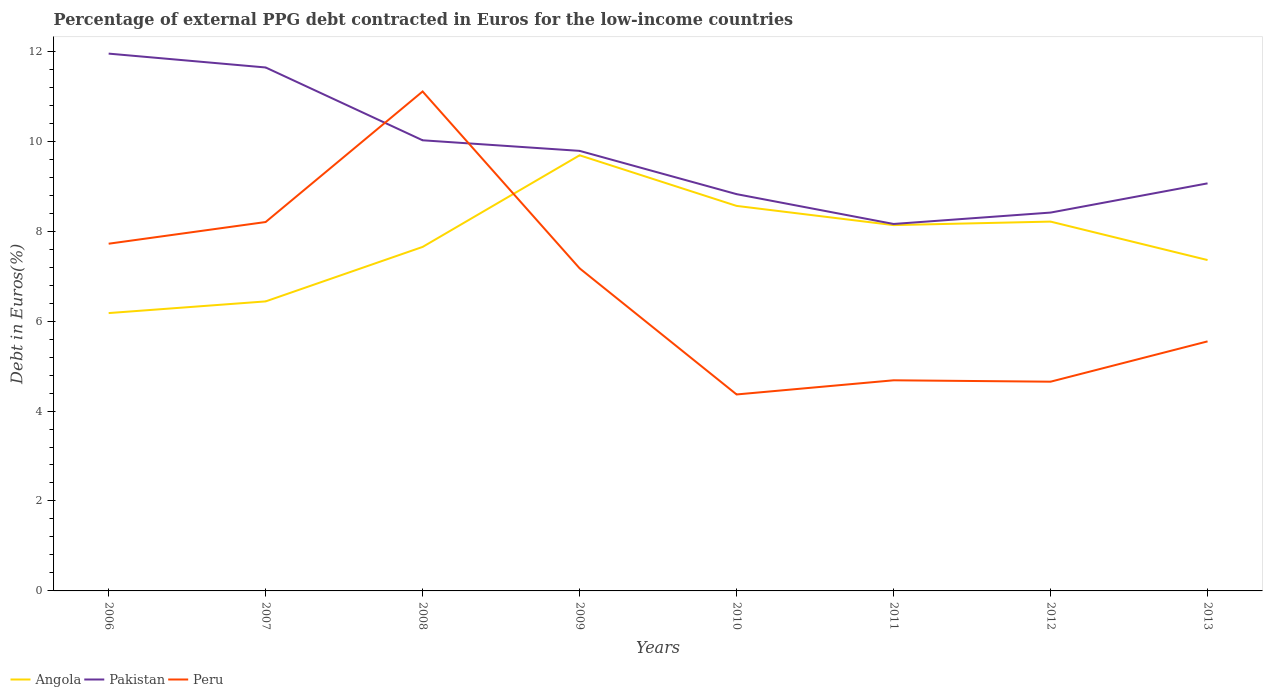How many different coloured lines are there?
Your response must be concise. 3. Does the line corresponding to Peru intersect with the line corresponding to Angola?
Offer a terse response. Yes. Is the number of lines equal to the number of legend labels?
Keep it short and to the point. Yes. Across all years, what is the maximum percentage of external PPG debt contracted in Euros in Angola?
Offer a terse response. 6.18. In which year was the percentage of external PPG debt contracted in Euros in Peru maximum?
Ensure brevity in your answer.  2010. What is the total percentage of external PPG debt contracted in Euros in Pakistan in the graph?
Make the answer very short. 2.88. What is the difference between the highest and the second highest percentage of external PPG debt contracted in Euros in Angola?
Give a very brief answer. 3.51. How many lines are there?
Your answer should be compact. 3. How many years are there in the graph?
Give a very brief answer. 8. Are the values on the major ticks of Y-axis written in scientific E-notation?
Keep it short and to the point. No. Does the graph contain any zero values?
Keep it short and to the point. No. Where does the legend appear in the graph?
Make the answer very short. Bottom left. What is the title of the graph?
Make the answer very short. Percentage of external PPG debt contracted in Euros for the low-income countries. What is the label or title of the X-axis?
Ensure brevity in your answer.  Years. What is the label or title of the Y-axis?
Ensure brevity in your answer.  Debt in Euros(%). What is the Debt in Euros(%) of Angola in 2006?
Offer a terse response. 6.18. What is the Debt in Euros(%) of Pakistan in 2006?
Ensure brevity in your answer.  11.95. What is the Debt in Euros(%) in Peru in 2006?
Keep it short and to the point. 7.72. What is the Debt in Euros(%) of Angola in 2007?
Ensure brevity in your answer.  6.44. What is the Debt in Euros(%) of Pakistan in 2007?
Offer a terse response. 11.64. What is the Debt in Euros(%) of Peru in 2007?
Offer a very short reply. 8.2. What is the Debt in Euros(%) in Angola in 2008?
Provide a short and direct response. 7.65. What is the Debt in Euros(%) of Pakistan in 2008?
Keep it short and to the point. 10.02. What is the Debt in Euros(%) in Peru in 2008?
Provide a short and direct response. 11.11. What is the Debt in Euros(%) of Angola in 2009?
Make the answer very short. 9.69. What is the Debt in Euros(%) of Pakistan in 2009?
Your answer should be compact. 9.78. What is the Debt in Euros(%) in Peru in 2009?
Make the answer very short. 7.17. What is the Debt in Euros(%) of Angola in 2010?
Your answer should be compact. 8.56. What is the Debt in Euros(%) of Pakistan in 2010?
Make the answer very short. 8.82. What is the Debt in Euros(%) in Peru in 2010?
Ensure brevity in your answer.  4.37. What is the Debt in Euros(%) of Angola in 2011?
Your answer should be compact. 8.13. What is the Debt in Euros(%) of Pakistan in 2011?
Give a very brief answer. 8.16. What is the Debt in Euros(%) in Peru in 2011?
Your response must be concise. 4.68. What is the Debt in Euros(%) of Angola in 2012?
Make the answer very short. 8.21. What is the Debt in Euros(%) of Pakistan in 2012?
Ensure brevity in your answer.  8.41. What is the Debt in Euros(%) in Peru in 2012?
Your answer should be compact. 4.65. What is the Debt in Euros(%) of Angola in 2013?
Your response must be concise. 7.36. What is the Debt in Euros(%) of Pakistan in 2013?
Ensure brevity in your answer.  9.06. What is the Debt in Euros(%) of Peru in 2013?
Provide a succinct answer. 5.55. Across all years, what is the maximum Debt in Euros(%) of Angola?
Your answer should be compact. 9.69. Across all years, what is the maximum Debt in Euros(%) of Pakistan?
Your answer should be very brief. 11.95. Across all years, what is the maximum Debt in Euros(%) of Peru?
Offer a very short reply. 11.11. Across all years, what is the minimum Debt in Euros(%) in Angola?
Offer a terse response. 6.18. Across all years, what is the minimum Debt in Euros(%) of Pakistan?
Make the answer very short. 8.16. Across all years, what is the minimum Debt in Euros(%) of Peru?
Offer a very short reply. 4.37. What is the total Debt in Euros(%) of Angola in the graph?
Ensure brevity in your answer.  62.21. What is the total Debt in Euros(%) of Pakistan in the graph?
Make the answer very short. 77.85. What is the total Debt in Euros(%) of Peru in the graph?
Keep it short and to the point. 53.45. What is the difference between the Debt in Euros(%) in Angola in 2006 and that in 2007?
Your answer should be very brief. -0.26. What is the difference between the Debt in Euros(%) of Pakistan in 2006 and that in 2007?
Offer a terse response. 0.31. What is the difference between the Debt in Euros(%) of Peru in 2006 and that in 2007?
Give a very brief answer. -0.48. What is the difference between the Debt in Euros(%) of Angola in 2006 and that in 2008?
Offer a terse response. -1.47. What is the difference between the Debt in Euros(%) of Pakistan in 2006 and that in 2008?
Provide a short and direct response. 1.93. What is the difference between the Debt in Euros(%) of Peru in 2006 and that in 2008?
Your response must be concise. -3.38. What is the difference between the Debt in Euros(%) of Angola in 2006 and that in 2009?
Give a very brief answer. -3.51. What is the difference between the Debt in Euros(%) in Pakistan in 2006 and that in 2009?
Make the answer very short. 2.16. What is the difference between the Debt in Euros(%) in Peru in 2006 and that in 2009?
Your answer should be compact. 0.55. What is the difference between the Debt in Euros(%) in Angola in 2006 and that in 2010?
Your response must be concise. -2.38. What is the difference between the Debt in Euros(%) of Pakistan in 2006 and that in 2010?
Provide a succinct answer. 3.12. What is the difference between the Debt in Euros(%) in Peru in 2006 and that in 2010?
Offer a very short reply. 3.35. What is the difference between the Debt in Euros(%) in Angola in 2006 and that in 2011?
Your response must be concise. -1.96. What is the difference between the Debt in Euros(%) of Pakistan in 2006 and that in 2011?
Your answer should be compact. 3.79. What is the difference between the Debt in Euros(%) of Peru in 2006 and that in 2011?
Ensure brevity in your answer.  3.04. What is the difference between the Debt in Euros(%) of Angola in 2006 and that in 2012?
Ensure brevity in your answer.  -2.03. What is the difference between the Debt in Euros(%) of Pakistan in 2006 and that in 2012?
Make the answer very short. 3.53. What is the difference between the Debt in Euros(%) of Peru in 2006 and that in 2012?
Your answer should be compact. 3.07. What is the difference between the Debt in Euros(%) of Angola in 2006 and that in 2013?
Provide a short and direct response. -1.18. What is the difference between the Debt in Euros(%) in Pakistan in 2006 and that in 2013?
Ensure brevity in your answer.  2.88. What is the difference between the Debt in Euros(%) of Peru in 2006 and that in 2013?
Provide a succinct answer. 2.17. What is the difference between the Debt in Euros(%) in Angola in 2007 and that in 2008?
Your response must be concise. -1.21. What is the difference between the Debt in Euros(%) of Pakistan in 2007 and that in 2008?
Your answer should be very brief. 1.62. What is the difference between the Debt in Euros(%) in Peru in 2007 and that in 2008?
Your response must be concise. -2.9. What is the difference between the Debt in Euros(%) in Angola in 2007 and that in 2009?
Your response must be concise. -3.25. What is the difference between the Debt in Euros(%) of Pakistan in 2007 and that in 2009?
Ensure brevity in your answer.  1.85. What is the difference between the Debt in Euros(%) in Peru in 2007 and that in 2009?
Keep it short and to the point. 1.03. What is the difference between the Debt in Euros(%) in Angola in 2007 and that in 2010?
Your answer should be very brief. -2.12. What is the difference between the Debt in Euros(%) in Pakistan in 2007 and that in 2010?
Your response must be concise. 2.82. What is the difference between the Debt in Euros(%) in Peru in 2007 and that in 2010?
Provide a succinct answer. 3.83. What is the difference between the Debt in Euros(%) in Angola in 2007 and that in 2011?
Provide a succinct answer. -1.7. What is the difference between the Debt in Euros(%) in Pakistan in 2007 and that in 2011?
Your answer should be compact. 3.48. What is the difference between the Debt in Euros(%) of Peru in 2007 and that in 2011?
Offer a terse response. 3.52. What is the difference between the Debt in Euros(%) in Angola in 2007 and that in 2012?
Offer a terse response. -1.77. What is the difference between the Debt in Euros(%) of Pakistan in 2007 and that in 2012?
Make the answer very short. 3.23. What is the difference between the Debt in Euros(%) in Peru in 2007 and that in 2012?
Offer a very short reply. 3.55. What is the difference between the Debt in Euros(%) of Angola in 2007 and that in 2013?
Ensure brevity in your answer.  -0.92. What is the difference between the Debt in Euros(%) in Pakistan in 2007 and that in 2013?
Your answer should be compact. 2.58. What is the difference between the Debt in Euros(%) in Peru in 2007 and that in 2013?
Provide a succinct answer. 2.65. What is the difference between the Debt in Euros(%) in Angola in 2008 and that in 2009?
Provide a short and direct response. -2.04. What is the difference between the Debt in Euros(%) in Pakistan in 2008 and that in 2009?
Provide a succinct answer. 0.24. What is the difference between the Debt in Euros(%) of Peru in 2008 and that in 2009?
Ensure brevity in your answer.  3.93. What is the difference between the Debt in Euros(%) in Angola in 2008 and that in 2010?
Give a very brief answer. -0.91. What is the difference between the Debt in Euros(%) of Pakistan in 2008 and that in 2010?
Give a very brief answer. 1.2. What is the difference between the Debt in Euros(%) of Peru in 2008 and that in 2010?
Make the answer very short. 6.74. What is the difference between the Debt in Euros(%) of Angola in 2008 and that in 2011?
Your answer should be compact. -0.48. What is the difference between the Debt in Euros(%) of Pakistan in 2008 and that in 2011?
Ensure brevity in your answer.  1.86. What is the difference between the Debt in Euros(%) in Peru in 2008 and that in 2011?
Keep it short and to the point. 6.42. What is the difference between the Debt in Euros(%) of Angola in 2008 and that in 2012?
Make the answer very short. -0.56. What is the difference between the Debt in Euros(%) in Pakistan in 2008 and that in 2012?
Your answer should be very brief. 1.61. What is the difference between the Debt in Euros(%) of Peru in 2008 and that in 2012?
Provide a succinct answer. 6.45. What is the difference between the Debt in Euros(%) of Angola in 2008 and that in 2013?
Keep it short and to the point. 0.29. What is the difference between the Debt in Euros(%) of Pakistan in 2008 and that in 2013?
Ensure brevity in your answer.  0.96. What is the difference between the Debt in Euros(%) in Peru in 2008 and that in 2013?
Make the answer very short. 5.56. What is the difference between the Debt in Euros(%) in Angola in 2009 and that in 2010?
Offer a terse response. 1.13. What is the difference between the Debt in Euros(%) of Pakistan in 2009 and that in 2010?
Give a very brief answer. 0.96. What is the difference between the Debt in Euros(%) in Peru in 2009 and that in 2010?
Your answer should be very brief. 2.8. What is the difference between the Debt in Euros(%) in Angola in 2009 and that in 2011?
Keep it short and to the point. 1.55. What is the difference between the Debt in Euros(%) in Pakistan in 2009 and that in 2011?
Your answer should be very brief. 1.63. What is the difference between the Debt in Euros(%) in Peru in 2009 and that in 2011?
Make the answer very short. 2.49. What is the difference between the Debt in Euros(%) in Angola in 2009 and that in 2012?
Provide a short and direct response. 1.47. What is the difference between the Debt in Euros(%) in Pakistan in 2009 and that in 2012?
Make the answer very short. 1.37. What is the difference between the Debt in Euros(%) of Peru in 2009 and that in 2012?
Make the answer very short. 2.52. What is the difference between the Debt in Euros(%) of Angola in 2009 and that in 2013?
Your response must be concise. 2.33. What is the difference between the Debt in Euros(%) in Pakistan in 2009 and that in 2013?
Your answer should be compact. 0.72. What is the difference between the Debt in Euros(%) in Peru in 2009 and that in 2013?
Your answer should be very brief. 1.62. What is the difference between the Debt in Euros(%) in Angola in 2010 and that in 2011?
Ensure brevity in your answer.  0.43. What is the difference between the Debt in Euros(%) of Pakistan in 2010 and that in 2011?
Provide a succinct answer. 0.66. What is the difference between the Debt in Euros(%) of Peru in 2010 and that in 2011?
Provide a succinct answer. -0.31. What is the difference between the Debt in Euros(%) of Angola in 2010 and that in 2012?
Provide a succinct answer. 0.35. What is the difference between the Debt in Euros(%) of Pakistan in 2010 and that in 2012?
Provide a succinct answer. 0.41. What is the difference between the Debt in Euros(%) of Peru in 2010 and that in 2012?
Keep it short and to the point. -0.28. What is the difference between the Debt in Euros(%) in Angola in 2010 and that in 2013?
Make the answer very short. 1.2. What is the difference between the Debt in Euros(%) in Pakistan in 2010 and that in 2013?
Your answer should be compact. -0.24. What is the difference between the Debt in Euros(%) in Peru in 2010 and that in 2013?
Offer a terse response. -1.18. What is the difference between the Debt in Euros(%) in Angola in 2011 and that in 2012?
Your answer should be compact. -0.08. What is the difference between the Debt in Euros(%) of Pakistan in 2011 and that in 2012?
Ensure brevity in your answer.  -0.25. What is the difference between the Debt in Euros(%) of Peru in 2011 and that in 2012?
Provide a short and direct response. 0.03. What is the difference between the Debt in Euros(%) in Angola in 2011 and that in 2013?
Your answer should be very brief. 0.78. What is the difference between the Debt in Euros(%) in Pakistan in 2011 and that in 2013?
Provide a succinct answer. -0.9. What is the difference between the Debt in Euros(%) of Peru in 2011 and that in 2013?
Ensure brevity in your answer.  -0.87. What is the difference between the Debt in Euros(%) in Angola in 2012 and that in 2013?
Your answer should be compact. 0.86. What is the difference between the Debt in Euros(%) in Pakistan in 2012 and that in 2013?
Ensure brevity in your answer.  -0.65. What is the difference between the Debt in Euros(%) in Peru in 2012 and that in 2013?
Ensure brevity in your answer.  -0.9. What is the difference between the Debt in Euros(%) of Angola in 2006 and the Debt in Euros(%) of Pakistan in 2007?
Offer a terse response. -5.46. What is the difference between the Debt in Euros(%) in Angola in 2006 and the Debt in Euros(%) in Peru in 2007?
Ensure brevity in your answer.  -2.02. What is the difference between the Debt in Euros(%) of Pakistan in 2006 and the Debt in Euros(%) of Peru in 2007?
Provide a short and direct response. 3.74. What is the difference between the Debt in Euros(%) in Angola in 2006 and the Debt in Euros(%) in Pakistan in 2008?
Give a very brief answer. -3.84. What is the difference between the Debt in Euros(%) in Angola in 2006 and the Debt in Euros(%) in Peru in 2008?
Keep it short and to the point. -4.93. What is the difference between the Debt in Euros(%) of Pakistan in 2006 and the Debt in Euros(%) of Peru in 2008?
Give a very brief answer. 0.84. What is the difference between the Debt in Euros(%) of Angola in 2006 and the Debt in Euros(%) of Pakistan in 2009?
Your answer should be very brief. -3.61. What is the difference between the Debt in Euros(%) of Angola in 2006 and the Debt in Euros(%) of Peru in 2009?
Ensure brevity in your answer.  -1. What is the difference between the Debt in Euros(%) of Pakistan in 2006 and the Debt in Euros(%) of Peru in 2009?
Keep it short and to the point. 4.77. What is the difference between the Debt in Euros(%) in Angola in 2006 and the Debt in Euros(%) in Pakistan in 2010?
Give a very brief answer. -2.64. What is the difference between the Debt in Euros(%) of Angola in 2006 and the Debt in Euros(%) of Peru in 2010?
Give a very brief answer. 1.81. What is the difference between the Debt in Euros(%) of Pakistan in 2006 and the Debt in Euros(%) of Peru in 2010?
Offer a terse response. 7.58. What is the difference between the Debt in Euros(%) in Angola in 2006 and the Debt in Euros(%) in Pakistan in 2011?
Your response must be concise. -1.98. What is the difference between the Debt in Euros(%) of Angola in 2006 and the Debt in Euros(%) of Peru in 2011?
Keep it short and to the point. 1.49. What is the difference between the Debt in Euros(%) in Pakistan in 2006 and the Debt in Euros(%) in Peru in 2011?
Give a very brief answer. 7.26. What is the difference between the Debt in Euros(%) in Angola in 2006 and the Debt in Euros(%) in Pakistan in 2012?
Ensure brevity in your answer.  -2.23. What is the difference between the Debt in Euros(%) of Angola in 2006 and the Debt in Euros(%) of Peru in 2012?
Your response must be concise. 1.53. What is the difference between the Debt in Euros(%) of Pakistan in 2006 and the Debt in Euros(%) of Peru in 2012?
Give a very brief answer. 7.29. What is the difference between the Debt in Euros(%) of Angola in 2006 and the Debt in Euros(%) of Pakistan in 2013?
Your answer should be very brief. -2.88. What is the difference between the Debt in Euros(%) of Angola in 2006 and the Debt in Euros(%) of Peru in 2013?
Offer a terse response. 0.63. What is the difference between the Debt in Euros(%) in Pakistan in 2006 and the Debt in Euros(%) in Peru in 2013?
Offer a very short reply. 6.4. What is the difference between the Debt in Euros(%) in Angola in 2007 and the Debt in Euros(%) in Pakistan in 2008?
Provide a short and direct response. -3.58. What is the difference between the Debt in Euros(%) in Angola in 2007 and the Debt in Euros(%) in Peru in 2008?
Offer a terse response. -4.67. What is the difference between the Debt in Euros(%) in Pakistan in 2007 and the Debt in Euros(%) in Peru in 2008?
Offer a very short reply. 0.53. What is the difference between the Debt in Euros(%) in Angola in 2007 and the Debt in Euros(%) in Pakistan in 2009?
Give a very brief answer. -3.35. What is the difference between the Debt in Euros(%) in Angola in 2007 and the Debt in Euros(%) in Peru in 2009?
Provide a short and direct response. -0.74. What is the difference between the Debt in Euros(%) of Pakistan in 2007 and the Debt in Euros(%) of Peru in 2009?
Give a very brief answer. 4.47. What is the difference between the Debt in Euros(%) in Angola in 2007 and the Debt in Euros(%) in Pakistan in 2010?
Ensure brevity in your answer.  -2.38. What is the difference between the Debt in Euros(%) of Angola in 2007 and the Debt in Euros(%) of Peru in 2010?
Provide a short and direct response. 2.07. What is the difference between the Debt in Euros(%) in Pakistan in 2007 and the Debt in Euros(%) in Peru in 2010?
Provide a succinct answer. 7.27. What is the difference between the Debt in Euros(%) of Angola in 2007 and the Debt in Euros(%) of Pakistan in 2011?
Keep it short and to the point. -1.72. What is the difference between the Debt in Euros(%) of Angola in 2007 and the Debt in Euros(%) of Peru in 2011?
Keep it short and to the point. 1.75. What is the difference between the Debt in Euros(%) of Pakistan in 2007 and the Debt in Euros(%) of Peru in 2011?
Provide a succinct answer. 6.96. What is the difference between the Debt in Euros(%) of Angola in 2007 and the Debt in Euros(%) of Pakistan in 2012?
Keep it short and to the point. -1.98. What is the difference between the Debt in Euros(%) of Angola in 2007 and the Debt in Euros(%) of Peru in 2012?
Your response must be concise. 1.79. What is the difference between the Debt in Euros(%) of Pakistan in 2007 and the Debt in Euros(%) of Peru in 2012?
Make the answer very short. 6.99. What is the difference between the Debt in Euros(%) in Angola in 2007 and the Debt in Euros(%) in Pakistan in 2013?
Your answer should be very brief. -2.62. What is the difference between the Debt in Euros(%) of Angola in 2007 and the Debt in Euros(%) of Peru in 2013?
Keep it short and to the point. 0.89. What is the difference between the Debt in Euros(%) of Pakistan in 2007 and the Debt in Euros(%) of Peru in 2013?
Your response must be concise. 6.09. What is the difference between the Debt in Euros(%) in Angola in 2008 and the Debt in Euros(%) in Pakistan in 2009?
Offer a very short reply. -2.14. What is the difference between the Debt in Euros(%) in Angola in 2008 and the Debt in Euros(%) in Peru in 2009?
Make the answer very short. 0.48. What is the difference between the Debt in Euros(%) of Pakistan in 2008 and the Debt in Euros(%) of Peru in 2009?
Provide a succinct answer. 2.85. What is the difference between the Debt in Euros(%) in Angola in 2008 and the Debt in Euros(%) in Pakistan in 2010?
Your answer should be compact. -1.17. What is the difference between the Debt in Euros(%) in Angola in 2008 and the Debt in Euros(%) in Peru in 2010?
Ensure brevity in your answer.  3.28. What is the difference between the Debt in Euros(%) in Pakistan in 2008 and the Debt in Euros(%) in Peru in 2010?
Provide a succinct answer. 5.65. What is the difference between the Debt in Euros(%) in Angola in 2008 and the Debt in Euros(%) in Pakistan in 2011?
Your response must be concise. -0.51. What is the difference between the Debt in Euros(%) of Angola in 2008 and the Debt in Euros(%) of Peru in 2011?
Keep it short and to the point. 2.97. What is the difference between the Debt in Euros(%) of Pakistan in 2008 and the Debt in Euros(%) of Peru in 2011?
Give a very brief answer. 5.34. What is the difference between the Debt in Euros(%) in Angola in 2008 and the Debt in Euros(%) in Pakistan in 2012?
Your response must be concise. -0.76. What is the difference between the Debt in Euros(%) of Angola in 2008 and the Debt in Euros(%) of Peru in 2012?
Provide a succinct answer. 3. What is the difference between the Debt in Euros(%) in Pakistan in 2008 and the Debt in Euros(%) in Peru in 2012?
Provide a succinct answer. 5.37. What is the difference between the Debt in Euros(%) of Angola in 2008 and the Debt in Euros(%) of Pakistan in 2013?
Make the answer very short. -1.41. What is the difference between the Debt in Euros(%) of Angola in 2008 and the Debt in Euros(%) of Peru in 2013?
Ensure brevity in your answer.  2.1. What is the difference between the Debt in Euros(%) in Pakistan in 2008 and the Debt in Euros(%) in Peru in 2013?
Provide a short and direct response. 4.47. What is the difference between the Debt in Euros(%) of Angola in 2009 and the Debt in Euros(%) of Pakistan in 2010?
Keep it short and to the point. 0.86. What is the difference between the Debt in Euros(%) of Angola in 2009 and the Debt in Euros(%) of Peru in 2010?
Offer a terse response. 5.32. What is the difference between the Debt in Euros(%) of Pakistan in 2009 and the Debt in Euros(%) of Peru in 2010?
Your response must be concise. 5.42. What is the difference between the Debt in Euros(%) of Angola in 2009 and the Debt in Euros(%) of Pakistan in 2011?
Give a very brief answer. 1.53. What is the difference between the Debt in Euros(%) in Angola in 2009 and the Debt in Euros(%) in Peru in 2011?
Make the answer very short. 5. What is the difference between the Debt in Euros(%) in Pakistan in 2009 and the Debt in Euros(%) in Peru in 2011?
Ensure brevity in your answer.  5.1. What is the difference between the Debt in Euros(%) of Angola in 2009 and the Debt in Euros(%) of Pakistan in 2012?
Make the answer very short. 1.27. What is the difference between the Debt in Euros(%) in Angola in 2009 and the Debt in Euros(%) in Peru in 2012?
Offer a very short reply. 5.03. What is the difference between the Debt in Euros(%) of Pakistan in 2009 and the Debt in Euros(%) of Peru in 2012?
Provide a succinct answer. 5.13. What is the difference between the Debt in Euros(%) of Angola in 2009 and the Debt in Euros(%) of Pakistan in 2013?
Keep it short and to the point. 0.62. What is the difference between the Debt in Euros(%) of Angola in 2009 and the Debt in Euros(%) of Peru in 2013?
Make the answer very short. 4.14. What is the difference between the Debt in Euros(%) of Pakistan in 2009 and the Debt in Euros(%) of Peru in 2013?
Keep it short and to the point. 4.24. What is the difference between the Debt in Euros(%) in Angola in 2010 and the Debt in Euros(%) in Pakistan in 2011?
Give a very brief answer. 0.4. What is the difference between the Debt in Euros(%) of Angola in 2010 and the Debt in Euros(%) of Peru in 2011?
Keep it short and to the point. 3.88. What is the difference between the Debt in Euros(%) of Pakistan in 2010 and the Debt in Euros(%) of Peru in 2011?
Your answer should be compact. 4.14. What is the difference between the Debt in Euros(%) of Angola in 2010 and the Debt in Euros(%) of Pakistan in 2012?
Offer a very short reply. 0.15. What is the difference between the Debt in Euros(%) in Angola in 2010 and the Debt in Euros(%) in Peru in 2012?
Give a very brief answer. 3.91. What is the difference between the Debt in Euros(%) of Pakistan in 2010 and the Debt in Euros(%) of Peru in 2012?
Your answer should be very brief. 4.17. What is the difference between the Debt in Euros(%) in Angola in 2010 and the Debt in Euros(%) in Pakistan in 2013?
Give a very brief answer. -0.5. What is the difference between the Debt in Euros(%) in Angola in 2010 and the Debt in Euros(%) in Peru in 2013?
Provide a short and direct response. 3.01. What is the difference between the Debt in Euros(%) of Pakistan in 2010 and the Debt in Euros(%) of Peru in 2013?
Offer a terse response. 3.27. What is the difference between the Debt in Euros(%) in Angola in 2011 and the Debt in Euros(%) in Pakistan in 2012?
Give a very brief answer. -0.28. What is the difference between the Debt in Euros(%) in Angola in 2011 and the Debt in Euros(%) in Peru in 2012?
Keep it short and to the point. 3.48. What is the difference between the Debt in Euros(%) of Pakistan in 2011 and the Debt in Euros(%) of Peru in 2012?
Offer a terse response. 3.51. What is the difference between the Debt in Euros(%) of Angola in 2011 and the Debt in Euros(%) of Pakistan in 2013?
Your response must be concise. -0.93. What is the difference between the Debt in Euros(%) in Angola in 2011 and the Debt in Euros(%) in Peru in 2013?
Provide a succinct answer. 2.58. What is the difference between the Debt in Euros(%) in Pakistan in 2011 and the Debt in Euros(%) in Peru in 2013?
Provide a succinct answer. 2.61. What is the difference between the Debt in Euros(%) in Angola in 2012 and the Debt in Euros(%) in Pakistan in 2013?
Your answer should be compact. -0.85. What is the difference between the Debt in Euros(%) in Angola in 2012 and the Debt in Euros(%) in Peru in 2013?
Give a very brief answer. 2.66. What is the difference between the Debt in Euros(%) of Pakistan in 2012 and the Debt in Euros(%) of Peru in 2013?
Ensure brevity in your answer.  2.86. What is the average Debt in Euros(%) of Angola per year?
Provide a succinct answer. 7.78. What is the average Debt in Euros(%) in Pakistan per year?
Provide a succinct answer. 9.73. What is the average Debt in Euros(%) of Peru per year?
Provide a succinct answer. 6.68. In the year 2006, what is the difference between the Debt in Euros(%) of Angola and Debt in Euros(%) of Pakistan?
Offer a very short reply. -5.77. In the year 2006, what is the difference between the Debt in Euros(%) in Angola and Debt in Euros(%) in Peru?
Offer a terse response. -1.54. In the year 2006, what is the difference between the Debt in Euros(%) in Pakistan and Debt in Euros(%) in Peru?
Give a very brief answer. 4.23. In the year 2007, what is the difference between the Debt in Euros(%) in Angola and Debt in Euros(%) in Pakistan?
Your response must be concise. -5.2. In the year 2007, what is the difference between the Debt in Euros(%) in Angola and Debt in Euros(%) in Peru?
Keep it short and to the point. -1.77. In the year 2007, what is the difference between the Debt in Euros(%) in Pakistan and Debt in Euros(%) in Peru?
Ensure brevity in your answer.  3.44. In the year 2008, what is the difference between the Debt in Euros(%) of Angola and Debt in Euros(%) of Pakistan?
Your answer should be very brief. -2.37. In the year 2008, what is the difference between the Debt in Euros(%) of Angola and Debt in Euros(%) of Peru?
Keep it short and to the point. -3.46. In the year 2008, what is the difference between the Debt in Euros(%) in Pakistan and Debt in Euros(%) in Peru?
Your answer should be compact. -1.09. In the year 2009, what is the difference between the Debt in Euros(%) in Angola and Debt in Euros(%) in Pakistan?
Ensure brevity in your answer.  -0.1. In the year 2009, what is the difference between the Debt in Euros(%) in Angola and Debt in Euros(%) in Peru?
Ensure brevity in your answer.  2.51. In the year 2009, what is the difference between the Debt in Euros(%) in Pakistan and Debt in Euros(%) in Peru?
Offer a terse response. 2.61. In the year 2010, what is the difference between the Debt in Euros(%) in Angola and Debt in Euros(%) in Pakistan?
Your response must be concise. -0.26. In the year 2010, what is the difference between the Debt in Euros(%) in Angola and Debt in Euros(%) in Peru?
Offer a terse response. 4.19. In the year 2010, what is the difference between the Debt in Euros(%) in Pakistan and Debt in Euros(%) in Peru?
Make the answer very short. 4.45. In the year 2011, what is the difference between the Debt in Euros(%) in Angola and Debt in Euros(%) in Pakistan?
Offer a very short reply. -0.03. In the year 2011, what is the difference between the Debt in Euros(%) of Angola and Debt in Euros(%) of Peru?
Offer a terse response. 3.45. In the year 2011, what is the difference between the Debt in Euros(%) of Pakistan and Debt in Euros(%) of Peru?
Provide a short and direct response. 3.48. In the year 2012, what is the difference between the Debt in Euros(%) in Angola and Debt in Euros(%) in Pakistan?
Make the answer very short. -0.2. In the year 2012, what is the difference between the Debt in Euros(%) of Angola and Debt in Euros(%) of Peru?
Your answer should be very brief. 3.56. In the year 2012, what is the difference between the Debt in Euros(%) of Pakistan and Debt in Euros(%) of Peru?
Your answer should be compact. 3.76. In the year 2013, what is the difference between the Debt in Euros(%) in Angola and Debt in Euros(%) in Pakistan?
Provide a succinct answer. -1.71. In the year 2013, what is the difference between the Debt in Euros(%) in Angola and Debt in Euros(%) in Peru?
Keep it short and to the point. 1.81. In the year 2013, what is the difference between the Debt in Euros(%) of Pakistan and Debt in Euros(%) of Peru?
Offer a terse response. 3.51. What is the ratio of the Debt in Euros(%) of Angola in 2006 to that in 2007?
Provide a short and direct response. 0.96. What is the ratio of the Debt in Euros(%) of Pakistan in 2006 to that in 2007?
Offer a terse response. 1.03. What is the ratio of the Debt in Euros(%) of Peru in 2006 to that in 2007?
Give a very brief answer. 0.94. What is the ratio of the Debt in Euros(%) in Angola in 2006 to that in 2008?
Provide a short and direct response. 0.81. What is the ratio of the Debt in Euros(%) in Pakistan in 2006 to that in 2008?
Provide a short and direct response. 1.19. What is the ratio of the Debt in Euros(%) in Peru in 2006 to that in 2008?
Provide a short and direct response. 0.7. What is the ratio of the Debt in Euros(%) in Angola in 2006 to that in 2009?
Offer a very short reply. 0.64. What is the ratio of the Debt in Euros(%) in Pakistan in 2006 to that in 2009?
Give a very brief answer. 1.22. What is the ratio of the Debt in Euros(%) of Peru in 2006 to that in 2009?
Provide a short and direct response. 1.08. What is the ratio of the Debt in Euros(%) in Angola in 2006 to that in 2010?
Give a very brief answer. 0.72. What is the ratio of the Debt in Euros(%) in Pakistan in 2006 to that in 2010?
Give a very brief answer. 1.35. What is the ratio of the Debt in Euros(%) in Peru in 2006 to that in 2010?
Ensure brevity in your answer.  1.77. What is the ratio of the Debt in Euros(%) of Angola in 2006 to that in 2011?
Make the answer very short. 0.76. What is the ratio of the Debt in Euros(%) of Pakistan in 2006 to that in 2011?
Offer a terse response. 1.46. What is the ratio of the Debt in Euros(%) in Peru in 2006 to that in 2011?
Ensure brevity in your answer.  1.65. What is the ratio of the Debt in Euros(%) of Angola in 2006 to that in 2012?
Your answer should be very brief. 0.75. What is the ratio of the Debt in Euros(%) in Pakistan in 2006 to that in 2012?
Keep it short and to the point. 1.42. What is the ratio of the Debt in Euros(%) of Peru in 2006 to that in 2012?
Make the answer very short. 1.66. What is the ratio of the Debt in Euros(%) of Angola in 2006 to that in 2013?
Your response must be concise. 0.84. What is the ratio of the Debt in Euros(%) in Pakistan in 2006 to that in 2013?
Make the answer very short. 1.32. What is the ratio of the Debt in Euros(%) in Peru in 2006 to that in 2013?
Make the answer very short. 1.39. What is the ratio of the Debt in Euros(%) of Angola in 2007 to that in 2008?
Make the answer very short. 0.84. What is the ratio of the Debt in Euros(%) of Pakistan in 2007 to that in 2008?
Ensure brevity in your answer.  1.16. What is the ratio of the Debt in Euros(%) of Peru in 2007 to that in 2008?
Your answer should be very brief. 0.74. What is the ratio of the Debt in Euros(%) of Angola in 2007 to that in 2009?
Ensure brevity in your answer.  0.66. What is the ratio of the Debt in Euros(%) in Pakistan in 2007 to that in 2009?
Your answer should be compact. 1.19. What is the ratio of the Debt in Euros(%) of Peru in 2007 to that in 2009?
Provide a short and direct response. 1.14. What is the ratio of the Debt in Euros(%) in Angola in 2007 to that in 2010?
Provide a succinct answer. 0.75. What is the ratio of the Debt in Euros(%) of Pakistan in 2007 to that in 2010?
Ensure brevity in your answer.  1.32. What is the ratio of the Debt in Euros(%) of Peru in 2007 to that in 2010?
Offer a terse response. 1.88. What is the ratio of the Debt in Euros(%) in Angola in 2007 to that in 2011?
Ensure brevity in your answer.  0.79. What is the ratio of the Debt in Euros(%) of Pakistan in 2007 to that in 2011?
Make the answer very short. 1.43. What is the ratio of the Debt in Euros(%) of Peru in 2007 to that in 2011?
Provide a succinct answer. 1.75. What is the ratio of the Debt in Euros(%) in Angola in 2007 to that in 2012?
Give a very brief answer. 0.78. What is the ratio of the Debt in Euros(%) in Pakistan in 2007 to that in 2012?
Offer a terse response. 1.38. What is the ratio of the Debt in Euros(%) of Peru in 2007 to that in 2012?
Offer a very short reply. 1.76. What is the ratio of the Debt in Euros(%) of Pakistan in 2007 to that in 2013?
Ensure brevity in your answer.  1.28. What is the ratio of the Debt in Euros(%) of Peru in 2007 to that in 2013?
Your answer should be very brief. 1.48. What is the ratio of the Debt in Euros(%) in Angola in 2008 to that in 2009?
Make the answer very short. 0.79. What is the ratio of the Debt in Euros(%) of Peru in 2008 to that in 2009?
Offer a terse response. 1.55. What is the ratio of the Debt in Euros(%) of Angola in 2008 to that in 2010?
Provide a short and direct response. 0.89. What is the ratio of the Debt in Euros(%) in Pakistan in 2008 to that in 2010?
Offer a very short reply. 1.14. What is the ratio of the Debt in Euros(%) of Peru in 2008 to that in 2010?
Your response must be concise. 2.54. What is the ratio of the Debt in Euros(%) in Angola in 2008 to that in 2011?
Your answer should be very brief. 0.94. What is the ratio of the Debt in Euros(%) in Pakistan in 2008 to that in 2011?
Provide a succinct answer. 1.23. What is the ratio of the Debt in Euros(%) of Peru in 2008 to that in 2011?
Give a very brief answer. 2.37. What is the ratio of the Debt in Euros(%) in Angola in 2008 to that in 2012?
Provide a succinct answer. 0.93. What is the ratio of the Debt in Euros(%) in Pakistan in 2008 to that in 2012?
Your answer should be compact. 1.19. What is the ratio of the Debt in Euros(%) in Peru in 2008 to that in 2012?
Provide a short and direct response. 2.39. What is the ratio of the Debt in Euros(%) in Angola in 2008 to that in 2013?
Make the answer very short. 1.04. What is the ratio of the Debt in Euros(%) in Pakistan in 2008 to that in 2013?
Offer a terse response. 1.11. What is the ratio of the Debt in Euros(%) in Peru in 2008 to that in 2013?
Keep it short and to the point. 2. What is the ratio of the Debt in Euros(%) in Angola in 2009 to that in 2010?
Ensure brevity in your answer.  1.13. What is the ratio of the Debt in Euros(%) of Pakistan in 2009 to that in 2010?
Your answer should be compact. 1.11. What is the ratio of the Debt in Euros(%) of Peru in 2009 to that in 2010?
Provide a succinct answer. 1.64. What is the ratio of the Debt in Euros(%) in Angola in 2009 to that in 2011?
Your response must be concise. 1.19. What is the ratio of the Debt in Euros(%) of Pakistan in 2009 to that in 2011?
Your answer should be very brief. 1.2. What is the ratio of the Debt in Euros(%) of Peru in 2009 to that in 2011?
Provide a succinct answer. 1.53. What is the ratio of the Debt in Euros(%) in Angola in 2009 to that in 2012?
Provide a succinct answer. 1.18. What is the ratio of the Debt in Euros(%) of Pakistan in 2009 to that in 2012?
Your answer should be compact. 1.16. What is the ratio of the Debt in Euros(%) of Peru in 2009 to that in 2012?
Your answer should be very brief. 1.54. What is the ratio of the Debt in Euros(%) in Angola in 2009 to that in 2013?
Your answer should be compact. 1.32. What is the ratio of the Debt in Euros(%) in Pakistan in 2009 to that in 2013?
Offer a very short reply. 1.08. What is the ratio of the Debt in Euros(%) of Peru in 2009 to that in 2013?
Provide a succinct answer. 1.29. What is the ratio of the Debt in Euros(%) in Angola in 2010 to that in 2011?
Give a very brief answer. 1.05. What is the ratio of the Debt in Euros(%) of Pakistan in 2010 to that in 2011?
Your response must be concise. 1.08. What is the ratio of the Debt in Euros(%) in Peru in 2010 to that in 2011?
Provide a succinct answer. 0.93. What is the ratio of the Debt in Euros(%) of Angola in 2010 to that in 2012?
Offer a terse response. 1.04. What is the ratio of the Debt in Euros(%) in Pakistan in 2010 to that in 2012?
Offer a terse response. 1.05. What is the ratio of the Debt in Euros(%) in Peru in 2010 to that in 2012?
Your answer should be compact. 0.94. What is the ratio of the Debt in Euros(%) of Angola in 2010 to that in 2013?
Your answer should be compact. 1.16. What is the ratio of the Debt in Euros(%) of Pakistan in 2010 to that in 2013?
Provide a succinct answer. 0.97. What is the ratio of the Debt in Euros(%) in Peru in 2010 to that in 2013?
Your response must be concise. 0.79. What is the ratio of the Debt in Euros(%) in Angola in 2011 to that in 2012?
Ensure brevity in your answer.  0.99. What is the ratio of the Debt in Euros(%) of Pakistan in 2011 to that in 2012?
Your answer should be very brief. 0.97. What is the ratio of the Debt in Euros(%) in Peru in 2011 to that in 2012?
Provide a succinct answer. 1.01. What is the ratio of the Debt in Euros(%) of Angola in 2011 to that in 2013?
Offer a very short reply. 1.11. What is the ratio of the Debt in Euros(%) in Pakistan in 2011 to that in 2013?
Provide a short and direct response. 0.9. What is the ratio of the Debt in Euros(%) of Peru in 2011 to that in 2013?
Provide a succinct answer. 0.84. What is the ratio of the Debt in Euros(%) in Angola in 2012 to that in 2013?
Your answer should be very brief. 1.12. What is the ratio of the Debt in Euros(%) of Pakistan in 2012 to that in 2013?
Keep it short and to the point. 0.93. What is the ratio of the Debt in Euros(%) of Peru in 2012 to that in 2013?
Offer a terse response. 0.84. What is the difference between the highest and the second highest Debt in Euros(%) of Angola?
Offer a very short reply. 1.13. What is the difference between the highest and the second highest Debt in Euros(%) of Pakistan?
Provide a succinct answer. 0.31. What is the difference between the highest and the second highest Debt in Euros(%) of Peru?
Provide a succinct answer. 2.9. What is the difference between the highest and the lowest Debt in Euros(%) in Angola?
Your answer should be compact. 3.51. What is the difference between the highest and the lowest Debt in Euros(%) in Pakistan?
Provide a short and direct response. 3.79. What is the difference between the highest and the lowest Debt in Euros(%) in Peru?
Ensure brevity in your answer.  6.74. 